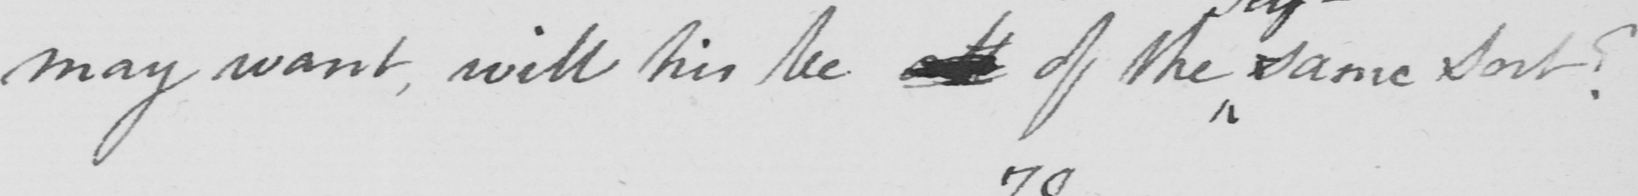Please provide the text content of this handwritten line. may want, will his be all of the same sort? 